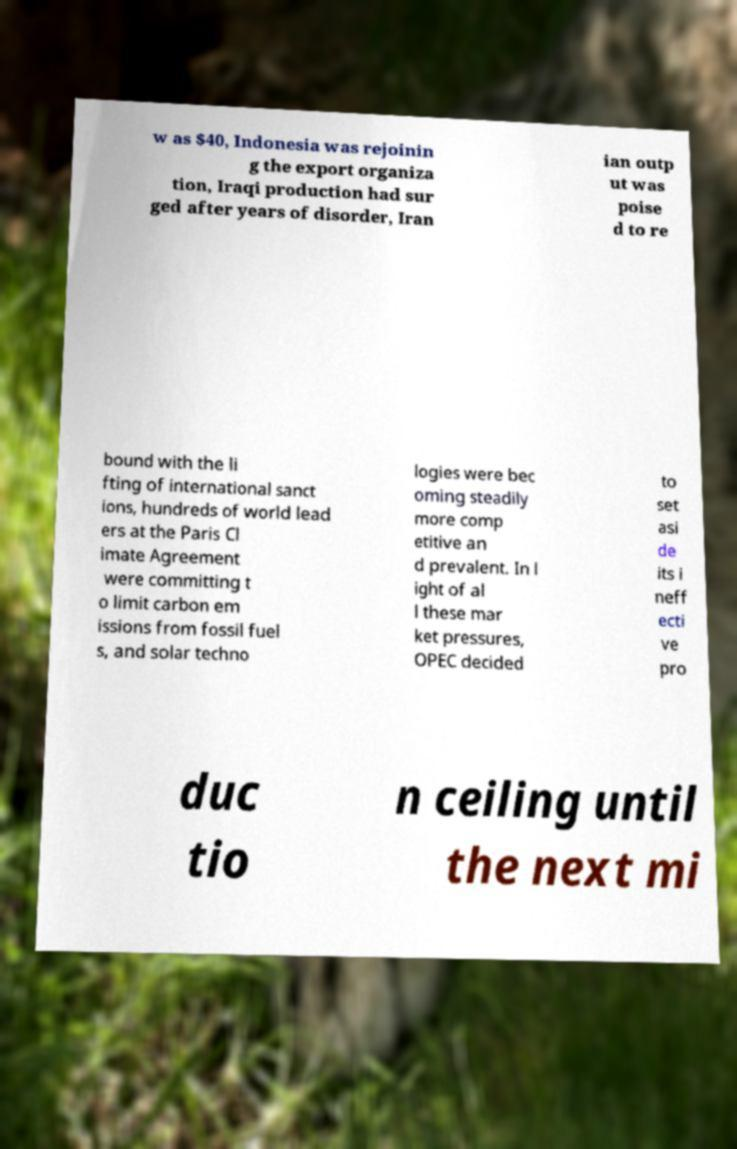I need the written content from this picture converted into text. Can you do that? w as $40, Indonesia was rejoinin g the export organiza tion, Iraqi production had sur ged after years of disorder, Iran ian outp ut was poise d to re bound with the li fting of international sanct ions, hundreds of world lead ers at the Paris Cl imate Agreement were committing t o limit carbon em issions from fossil fuel s, and solar techno logies were bec oming steadily more comp etitive an d prevalent. In l ight of al l these mar ket pressures, OPEC decided to set asi de its i neff ecti ve pro duc tio n ceiling until the next mi 